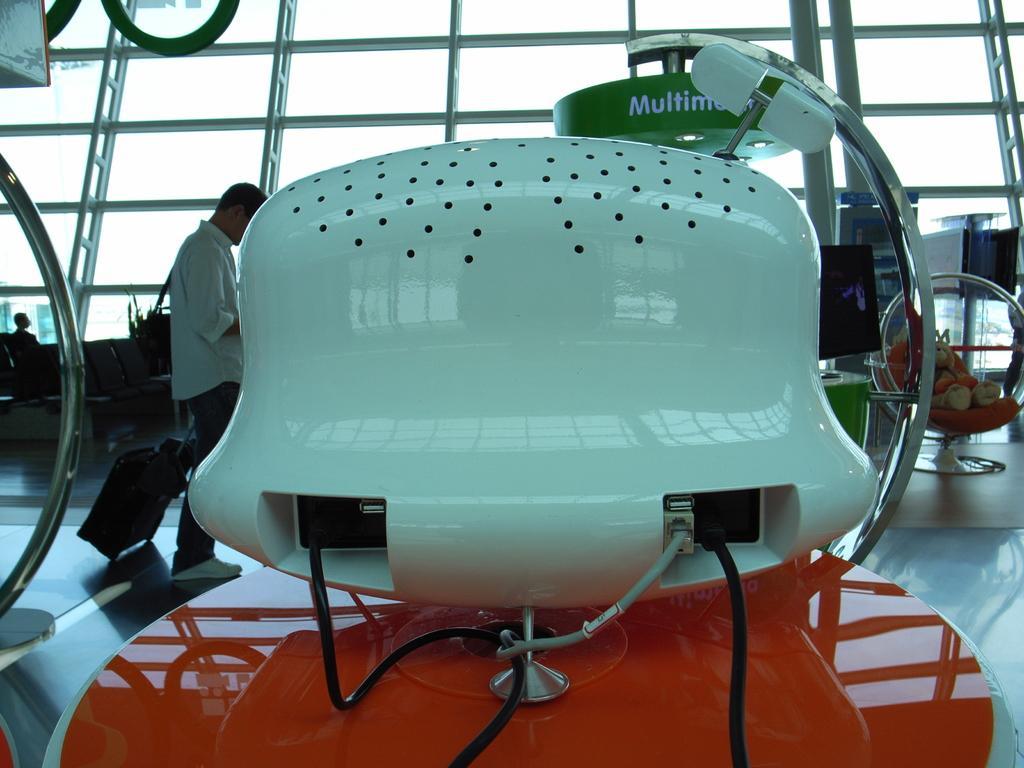Please provide a concise description of this image. In this image we can see an electronic device and in the background there are a few chairs, a person is holding a trolley bag and there are iron rods, a doll on the chair. 